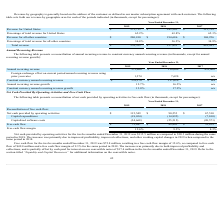According to Cornerstone Ondemand's financial document, What was the reason behind the increase of net cash provided by operating activities between 2018 and 2019? The increase was primarily due to improved profitability, improved collections, and other working capital changes. The document states: "period in 2018. The increase was primarily due to improved profitability, improved collections, and other working capital changes in 2019 when compare..." Also, What was the net cash provided by operating activities in 2017? According to the financial document, $67,510 (in thousands). The relevant text states: "ided by operating activities $ 115,549 $ 90,253 $ 67,510..." Also, What was the free cash flow in 2019? According to the financial document, $72,847 (in thousands). The relevant text states: "Free cash flow $ 72,847 $ 49,843 $ 39,839..." Also, can you calculate: What was the average net cash provided by operating activities from 2017-2019? To answer this question, I need to perform calculations using the financial data. The calculation is: ($115,549+$90,253+$67,510)/(2019-2017+1), which equals 91104 (in thousands). This is based on the information: "ided by operating activities $ 115,549 $ 90,253 $ 67,510 Net cash provided by operating activities $ 115,549 $ 90,253 $ 67,510 cash provided by operating activities $ 115,549 $ 90,253 $ 67,510..." The key data points involved are: 115,549, 67,510, 90,253. Also, can you calculate: What was the change in free flow cash margin between 2017 and 2018? Based on the calculation: (9.3%-8.3%), the result is 1 (percentage). This is based on the information: "Free cash flow margin 12.6% 9.3% 8.3% Free cash flow margin 12.6% 9.3% 8.3%..." The key data points involved are: 8.3, 9.3. Also, can you calculate: What was the change in free cash flow between 2018 and 2019? Based on the calculation: ($72,847-$49,843), the result is 23004 (in thousands). This is based on the information: "Free cash flow $ 72,847 $ 49,843 $ 39,839 Free cash flow $ 72,847 $ 49,843 $ 39,839..." The key data points involved are: 49,843, 72,847. 